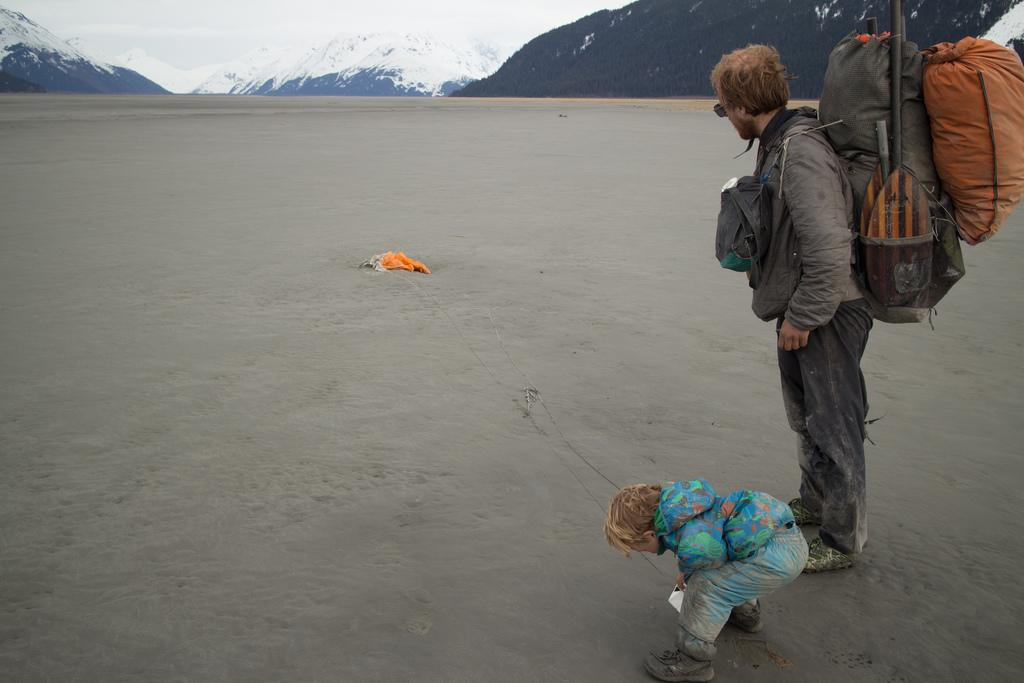What is the man in the image wearing on his back? The man is wearing a backpack. What type of eyewear is the man wearing in the image? The man is wearing sunglasses. Who else is present in the image besides the man? There is a boy in the image. What is on the ground in the image? There is a cloth on the ground. What type of landscape can be seen in the background of the image? There are mountains visible in the image, and they have snow on them. What type of pets are visible in the image? There are no pets visible in the image. What type of expression does the man have on his face in the image? The provided facts do not mention the man's facial expression, so we cannot determine if he is smiling or not. 